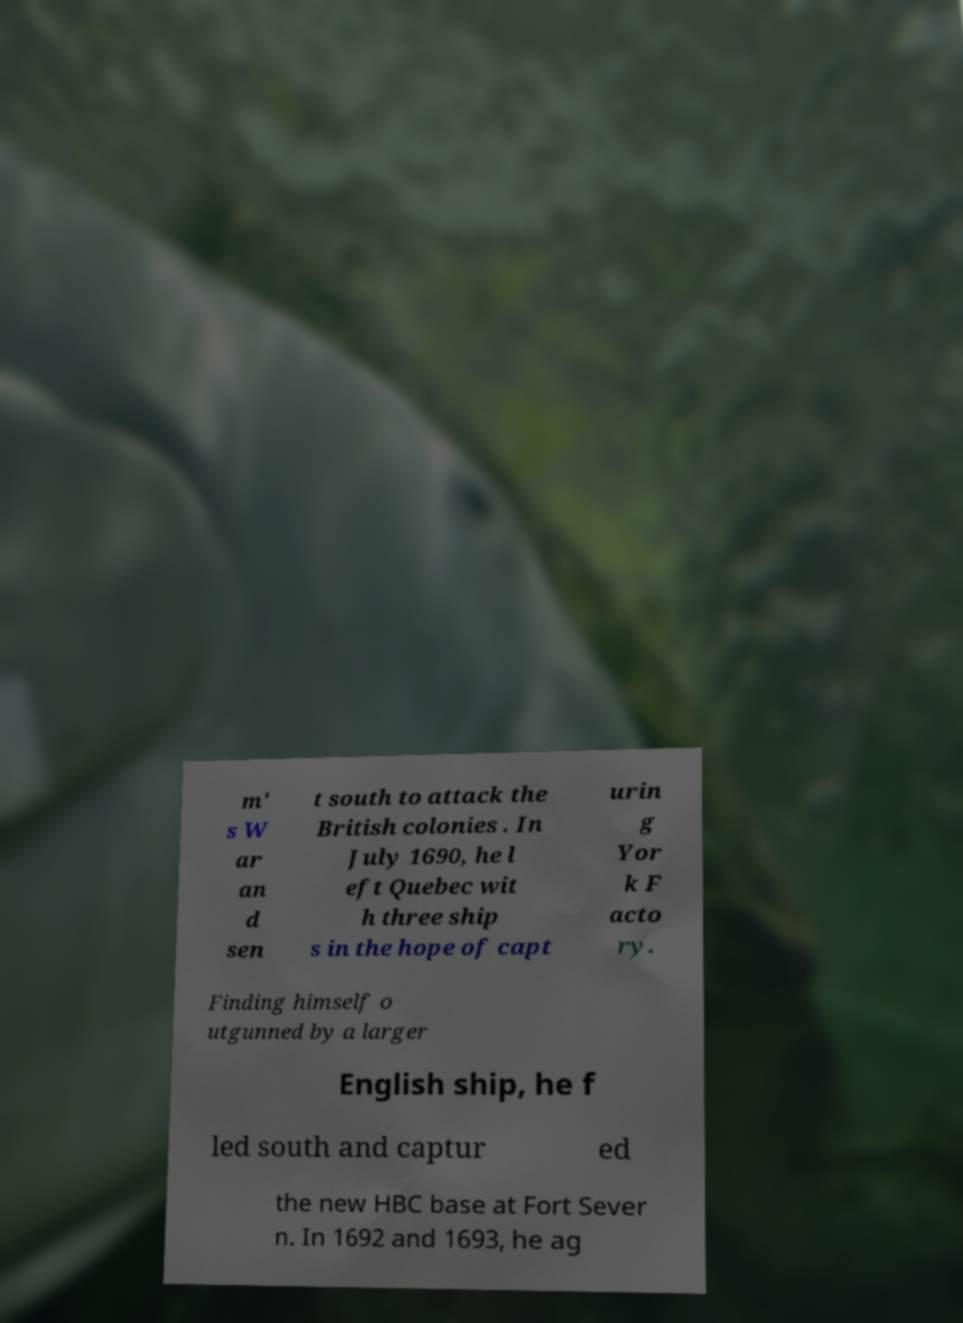Can you read and provide the text displayed in the image?This photo seems to have some interesting text. Can you extract and type it out for me? m' s W ar an d sen t south to attack the British colonies . In July 1690, he l eft Quebec wit h three ship s in the hope of capt urin g Yor k F acto ry. Finding himself o utgunned by a larger English ship, he f led south and captur ed the new HBC base at Fort Sever n. In 1692 and 1693, he ag 